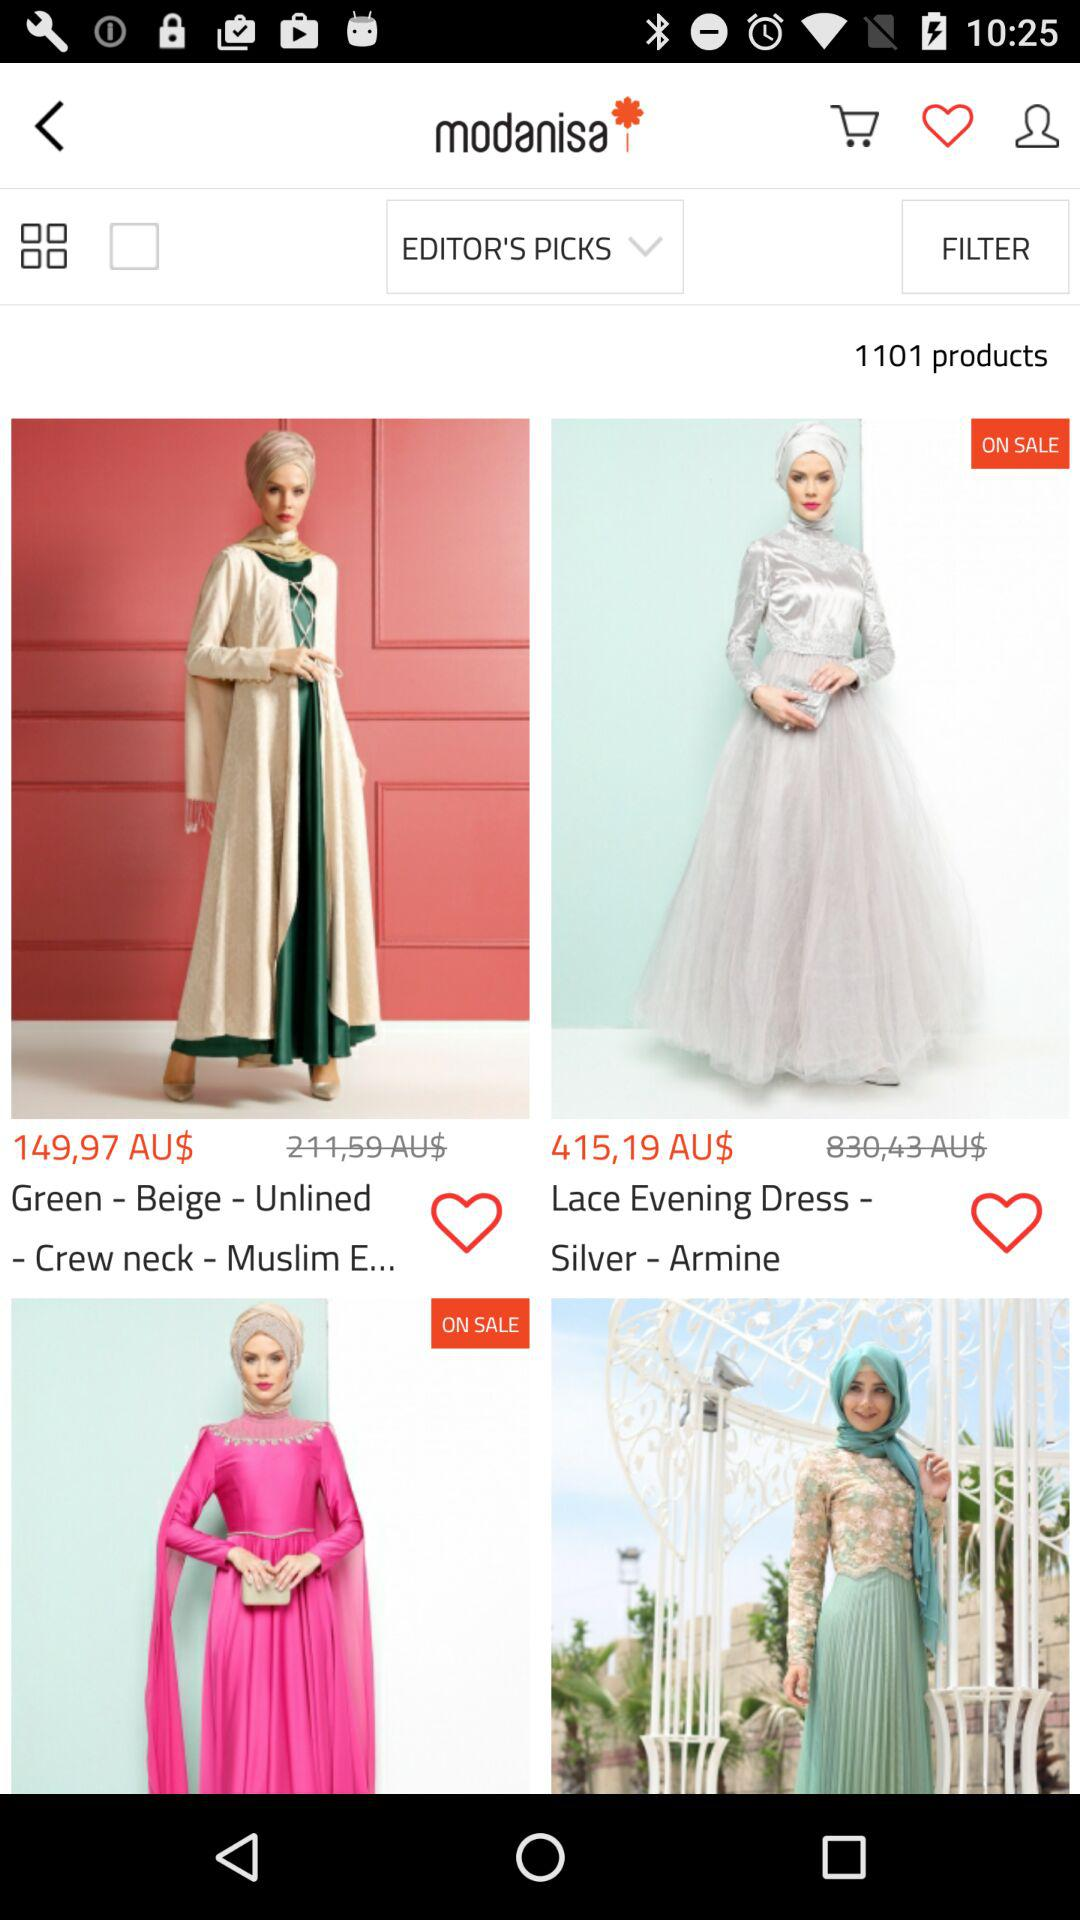What is the price of the dress that is on sale? The price is AU$415,19. 